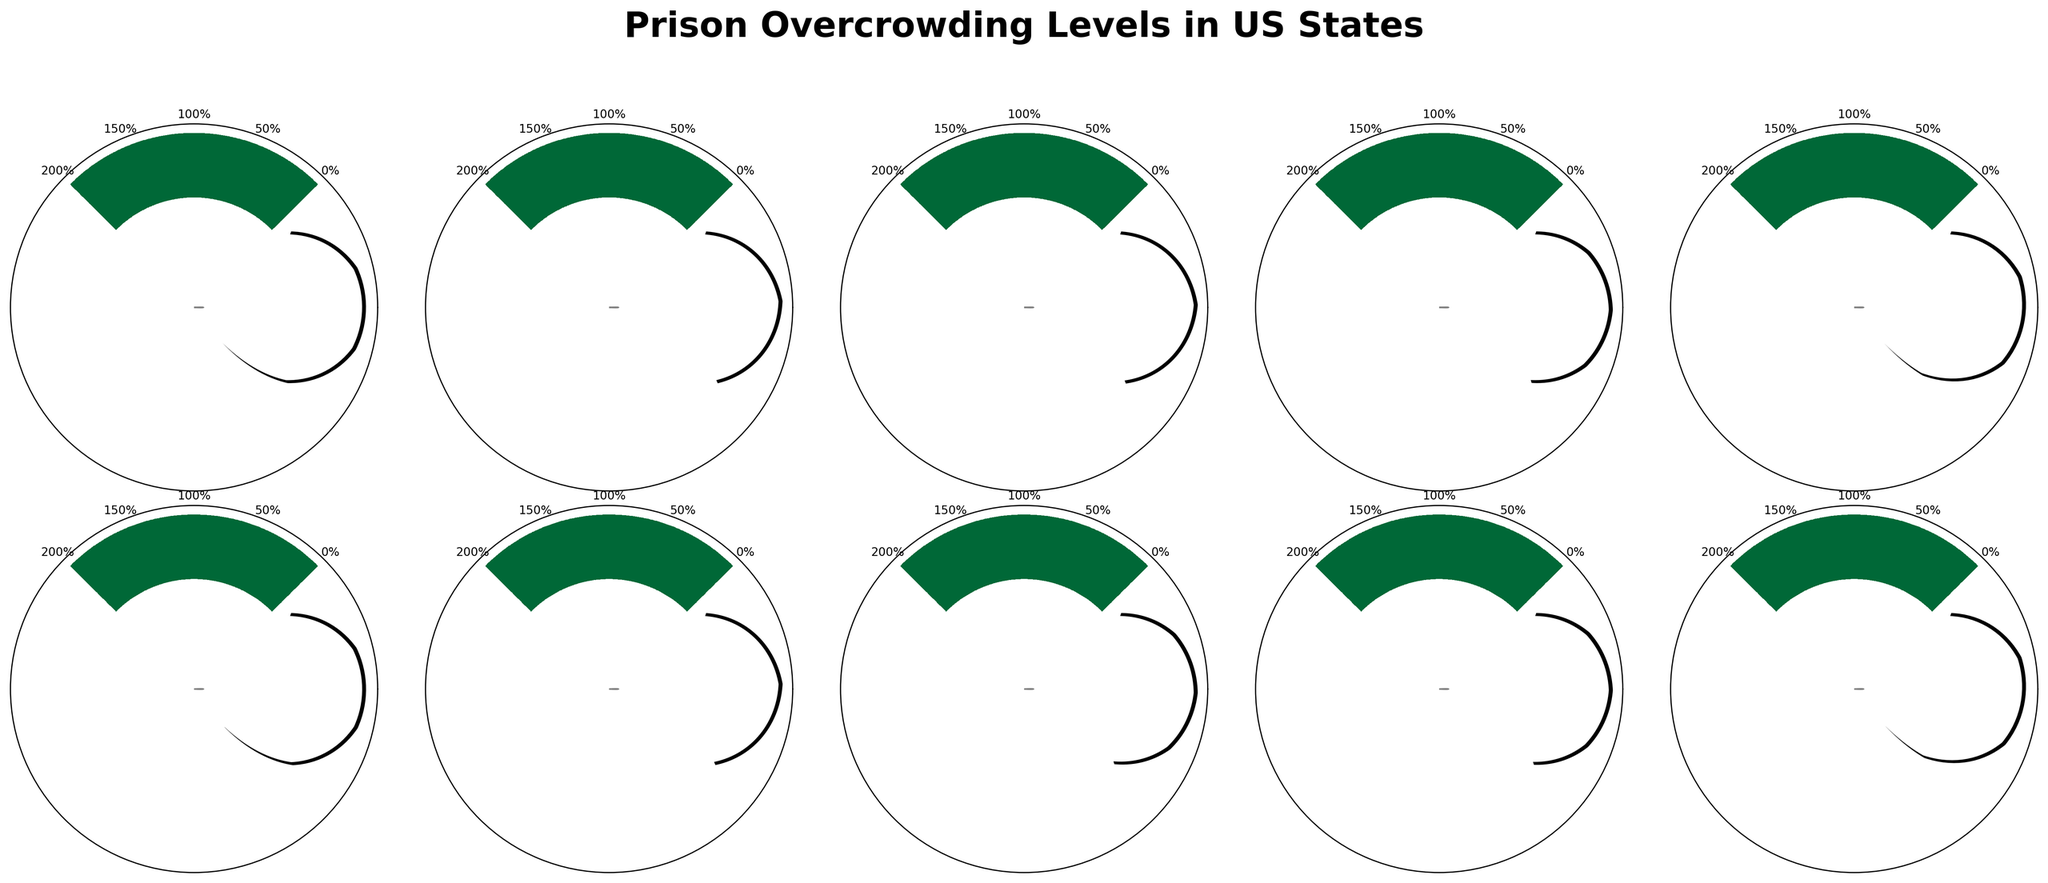Which state has the highest overcrowding percentage? By examining the figure, it's clear that Illinois leads in overcrowding with 150%. This is indicated by the needle position and the value shown on the figure.
Answer: Illinois How does California's overcrowding percentage compare to Texas? California has an overcrowding percentage of 135%, while Texas has 95%. By subtracting Texas' percentage from California's, we see that California exceeds Texas by 40%.
Answer: California is 40% higher What's the average overcrowding percentage of all the states? First, sum up the percentages: 135 + 95 + 98 + 102 + 150 + 132 + 96 + 103 + 101 + 149 = 1161. Then, divide by the number of states, which is 10, to get the average: 1161 / 10 = 116.1
Answer: 116.1 Which states have their overcrowding percentages shown in red? To identify states with red percentage values, look for those exceeding 100%. These states are California (135%), New York (102%), Illinois (150%), Georgia (103%), Pennsylvania (101%), and Louisiana (149%)
Answer: California, New York, Illinois, Georgia, Pennsylvania, Louisiana Do any states have overcrowding percentages below 100%? If so, which ones? The states with percentage values below 100% are Texas (95%), Florida (98%), Ohio (132%), and Michigan (96%). By scanning the gauge charts, these states are clearly marked.
Answer: Texas, Florida, Michigan What's the difference in overcrowding percentage between Illinois and Pennsylvania? Illinois has an overcrowding rate of 150%, whereas Pennsylvania stands at 101%. Subtracting Pennsylvania's percentage from Illinois' gives us: 150 - 101 = 49%.
Answer: 49% List the states with overcrowding percentages that fall within 90-100% range. Checking the indicated percentages, both Texas (95%) and Michigan (96%) fall in the specified range of 90-100%.
Answer: Texas, Michigan Between Michigan and Pennsylvania, which state is closer to 100% overcrowding? Michigan is at 96% and Pennsylvania is at 101%. Since 101% is closer to 100% than 96%, Pennsylvania is evidently nearer to this benchmark.
Answer: Pennsylvania Which states needle is pointing towards more than 125% on the gauge chart? States whose overcrowding percentages exceed 125% include California (135%), Illinois (150%), and Louisiana (149%).
Answer: California, Illinois, Louisiana 